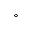<formula> <loc_0><loc_0><loc_500><loc_500>^ { \circ }</formula> 